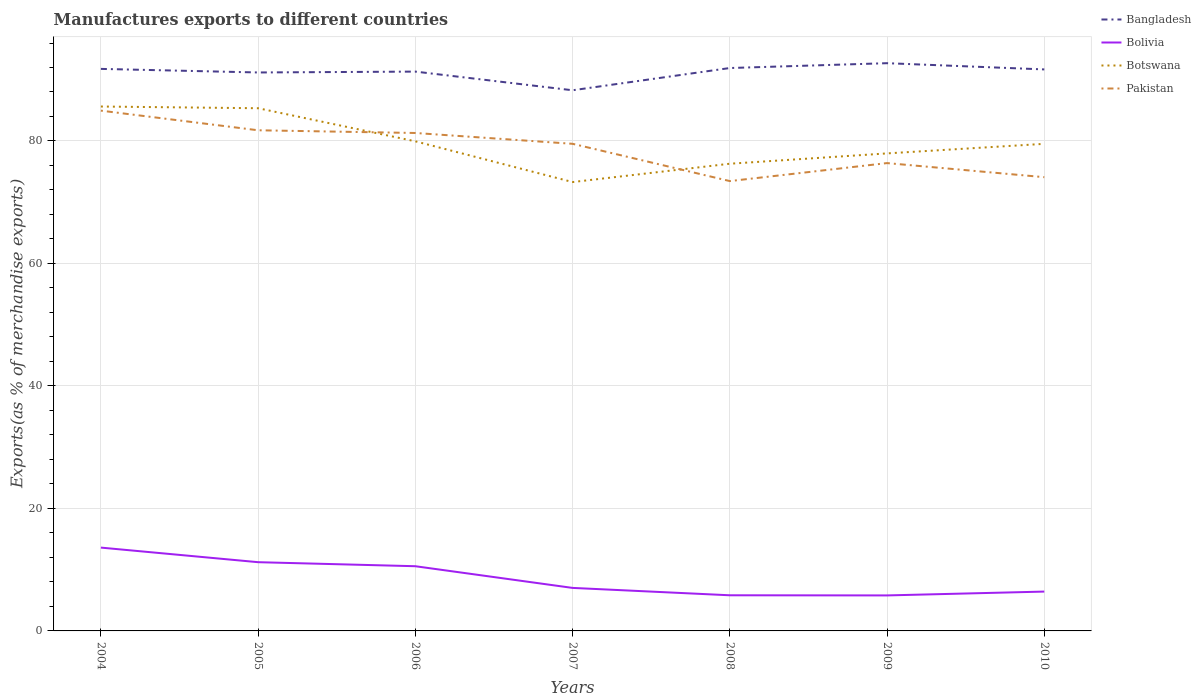Does the line corresponding to Bolivia intersect with the line corresponding to Bangladesh?
Provide a succinct answer. No. Across all years, what is the maximum percentage of exports to different countries in Bolivia?
Offer a terse response. 5.8. In which year was the percentage of exports to different countries in Pakistan maximum?
Keep it short and to the point. 2008. What is the total percentage of exports to different countries in Bangladesh in the graph?
Ensure brevity in your answer.  0.58. What is the difference between the highest and the second highest percentage of exports to different countries in Bolivia?
Your answer should be very brief. 7.81. How many years are there in the graph?
Provide a short and direct response. 7. What is the difference between two consecutive major ticks on the Y-axis?
Ensure brevity in your answer.  20. Does the graph contain grids?
Keep it short and to the point. Yes. How many legend labels are there?
Ensure brevity in your answer.  4. How are the legend labels stacked?
Keep it short and to the point. Vertical. What is the title of the graph?
Your response must be concise. Manufactures exports to different countries. Does "Low income" appear as one of the legend labels in the graph?
Provide a short and direct response. No. What is the label or title of the X-axis?
Your answer should be very brief. Years. What is the label or title of the Y-axis?
Keep it short and to the point. Exports(as % of merchandise exports). What is the Exports(as % of merchandise exports) of Bangladesh in 2004?
Provide a short and direct response. 91.77. What is the Exports(as % of merchandise exports) in Bolivia in 2004?
Offer a terse response. 13.61. What is the Exports(as % of merchandise exports) of Botswana in 2004?
Keep it short and to the point. 85.63. What is the Exports(as % of merchandise exports) of Pakistan in 2004?
Give a very brief answer. 84.96. What is the Exports(as % of merchandise exports) in Bangladesh in 2005?
Offer a terse response. 91.19. What is the Exports(as % of merchandise exports) of Bolivia in 2005?
Your answer should be compact. 11.22. What is the Exports(as % of merchandise exports) of Botswana in 2005?
Offer a terse response. 85.35. What is the Exports(as % of merchandise exports) in Pakistan in 2005?
Offer a very short reply. 81.75. What is the Exports(as % of merchandise exports) of Bangladesh in 2006?
Offer a very short reply. 91.33. What is the Exports(as % of merchandise exports) in Bolivia in 2006?
Your answer should be very brief. 10.56. What is the Exports(as % of merchandise exports) in Botswana in 2006?
Keep it short and to the point. 79.95. What is the Exports(as % of merchandise exports) in Pakistan in 2006?
Keep it short and to the point. 81.31. What is the Exports(as % of merchandise exports) in Bangladesh in 2007?
Your response must be concise. 88.28. What is the Exports(as % of merchandise exports) of Bolivia in 2007?
Give a very brief answer. 7.02. What is the Exports(as % of merchandise exports) in Botswana in 2007?
Provide a succinct answer. 73.3. What is the Exports(as % of merchandise exports) in Pakistan in 2007?
Give a very brief answer. 79.54. What is the Exports(as % of merchandise exports) in Bangladesh in 2008?
Offer a very short reply. 91.92. What is the Exports(as % of merchandise exports) in Bolivia in 2008?
Offer a very short reply. 5.82. What is the Exports(as % of merchandise exports) in Botswana in 2008?
Keep it short and to the point. 76.29. What is the Exports(as % of merchandise exports) in Pakistan in 2008?
Give a very brief answer. 73.45. What is the Exports(as % of merchandise exports) of Bangladesh in 2009?
Provide a short and direct response. 92.7. What is the Exports(as % of merchandise exports) in Bolivia in 2009?
Provide a short and direct response. 5.8. What is the Exports(as % of merchandise exports) of Botswana in 2009?
Your answer should be very brief. 77.97. What is the Exports(as % of merchandise exports) in Pakistan in 2009?
Your answer should be very brief. 76.39. What is the Exports(as % of merchandise exports) in Bangladesh in 2010?
Your answer should be very brief. 91.69. What is the Exports(as % of merchandise exports) of Bolivia in 2010?
Offer a terse response. 6.42. What is the Exports(as % of merchandise exports) in Botswana in 2010?
Give a very brief answer. 79.54. What is the Exports(as % of merchandise exports) of Pakistan in 2010?
Keep it short and to the point. 74.09. Across all years, what is the maximum Exports(as % of merchandise exports) of Bangladesh?
Give a very brief answer. 92.7. Across all years, what is the maximum Exports(as % of merchandise exports) in Bolivia?
Offer a very short reply. 13.61. Across all years, what is the maximum Exports(as % of merchandise exports) in Botswana?
Your answer should be compact. 85.63. Across all years, what is the maximum Exports(as % of merchandise exports) in Pakistan?
Offer a very short reply. 84.96. Across all years, what is the minimum Exports(as % of merchandise exports) of Bangladesh?
Your answer should be compact. 88.28. Across all years, what is the minimum Exports(as % of merchandise exports) of Bolivia?
Ensure brevity in your answer.  5.8. Across all years, what is the minimum Exports(as % of merchandise exports) of Botswana?
Your answer should be very brief. 73.3. Across all years, what is the minimum Exports(as % of merchandise exports) of Pakistan?
Make the answer very short. 73.45. What is the total Exports(as % of merchandise exports) of Bangladesh in the graph?
Ensure brevity in your answer.  638.88. What is the total Exports(as % of merchandise exports) of Bolivia in the graph?
Your response must be concise. 60.46. What is the total Exports(as % of merchandise exports) in Botswana in the graph?
Make the answer very short. 558.02. What is the total Exports(as % of merchandise exports) of Pakistan in the graph?
Your response must be concise. 551.49. What is the difference between the Exports(as % of merchandise exports) in Bangladesh in 2004 and that in 2005?
Give a very brief answer. 0.58. What is the difference between the Exports(as % of merchandise exports) in Bolivia in 2004 and that in 2005?
Offer a very short reply. 2.38. What is the difference between the Exports(as % of merchandise exports) of Botswana in 2004 and that in 2005?
Keep it short and to the point. 0.28. What is the difference between the Exports(as % of merchandise exports) of Pakistan in 2004 and that in 2005?
Provide a succinct answer. 3.21. What is the difference between the Exports(as % of merchandise exports) of Bangladesh in 2004 and that in 2006?
Your answer should be very brief. 0.44. What is the difference between the Exports(as % of merchandise exports) in Bolivia in 2004 and that in 2006?
Your answer should be compact. 3.04. What is the difference between the Exports(as % of merchandise exports) of Botswana in 2004 and that in 2006?
Your answer should be compact. 5.68. What is the difference between the Exports(as % of merchandise exports) of Pakistan in 2004 and that in 2006?
Provide a succinct answer. 3.65. What is the difference between the Exports(as % of merchandise exports) in Bangladesh in 2004 and that in 2007?
Make the answer very short. 3.49. What is the difference between the Exports(as % of merchandise exports) in Bolivia in 2004 and that in 2007?
Your response must be concise. 6.58. What is the difference between the Exports(as % of merchandise exports) of Botswana in 2004 and that in 2007?
Your response must be concise. 12.34. What is the difference between the Exports(as % of merchandise exports) in Pakistan in 2004 and that in 2007?
Provide a succinct answer. 5.42. What is the difference between the Exports(as % of merchandise exports) in Bangladesh in 2004 and that in 2008?
Keep it short and to the point. -0.14. What is the difference between the Exports(as % of merchandise exports) in Bolivia in 2004 and that in 2008?
Provide a succinct answer. 7.78. What is the difference between the Exports(as % of merchandise exports) in Botswana in 2004 and that in 2008?
Offer a very short reply. 9.34. What is the difference between the Exports(as % of merchandise exports) of Pakistan in 2004 and that in 2008?
Provide a short and direct response. 11.5. What is the difference between the Exports(as % of merchandise exports) of Bangladesh in 2004 and that in 2009?
Provide a short and direct response. -0.93. What is the difference between the Exports(as % of merchandise exports) in Bolivia in 2004 and that in 2009?
Offer a terse response. 7.81. What is the difference between the Exports(as % of merchandise exports) in Botswana in 2004 and that in 2009?
Give a very brief answer. 7.66. What is the difference between the Exports(as % of merchandise exports) in Pakistan in 2004 and that in 2009?
Your answer should be compact. 8.56. What is the difference between the Exports(as % of merchandise exports) in Bangladesh in 2004 and that in 2010?
Your answer should be very brief. 0.09. What is the difference between the Exports(as % of merchandise exports) of Bolivia in 2004 and that in 2010?
Give a very brief answer. 7.18. What is the difference between the Exports(as % of merchandise exports) in Botswana in 2004 and that in 2010?
Ensure brevity in your answer.  6.09. What is the difference between the Exports(as % of merchandise exports) of Pakistan in 2004 and that in 2010?
Offer a very short reply. 10.87. What is the difference between the Exports(as % of merchandise exports) of Bangladesh in 2005 and that in 2006?
Ensure brevity in your answer.  -0.14. What is the difference between the Exports(as % of merchandise exports) of Bolivia in 2005 and that in 2006?
Give a very brief answer. 0.66. What is the difference between the Exports(as % of merchandise exports) of Botswana in 2005 and that in 2006?
Keep it short and to the point. 5.4. What is the difference between the Exports(as % of merchandise exports) of Pakistan in 2005 and that in 2006?
Ensure brevity in your answer.  0.44. What is the difference between the Exports(as % of merchandise exports) of Bangladesh in 2005 and that in 2007?
Keep it short and to the point. 2.91. What is the difference between the Exports(as % of merchandise exports) in Bolivia in 2005 and that in 2007?
Your answer should be compact. 4.2. What is the difference between the Exports(as % of merchandise exports) in Botswana in 2005 and that in 2007?
Give a very brief answer. 12.05. What is the difference between the Exports(as % of merchandise exports) of Pakistan in 2005 and that in 2007?
Keep it short and to the point. 2.21. What is the difference between the Exports(as % of merchandise exports) in Bangladesh in 2005 and that in 2008?
Your response must be concise. -0.73. What is the difference between the Exports(as % of merchandise exports) of Bolivia in 2005 and that in 2008?
Your response must be concise. 5.4. What is the difference between the Exports(as % of merchandise exports) of Botswana in 2005 and that in 2008?
Ensure brevity in your answer.  9.06. What is the difference between the Exports(as % of merchandise exports) of Pakistan in 2005 and that in 2008?
Make the answer very short. 8.3. What is the difference between the Exports(as % of merchandise exports) in Bangladesh in 2005 and that in 2009?
Your answer should be very brief. -1.52. What is the difference between the Exports(as % of merchandise exports) of Bolivia in 2005 and that in 2009?
Your answer should be compact. 5.43. What is the difference between the Exports(as % of merchandise exports) of Botswana in 2005 and that in 2009?
Your response must be concise. 7.38. What is the difference between the Exports(as % of merchandise exports) of Pakistan in 2005 and that in 2009?
Offer a terse response. 5.36. What is the difference between the Exports(as % of merchandise exports) in Bangladesh in 2005 and that in 2010?
Keep it short and to the point. -0.5. What is the difference between the Exports(as % of merchandise exports) of Bolivia in 2005 and that in 2010?
Give a very brief answer. 4.8. What is the difference between the Exports(as % of merchandise exports) of Botswana in 2005 and that in 2010?
Your response must be concise. 5.81. What is the difference between the Exports(as % of merchandise exports) in Pakistan in 2005 and that in 2010?
Give a very brief answer. 7.66. What is the difference between the Exports(as % of merchandise exports) in Bangladesh in 2006 and that in 2007?
Your answer should be compact. 3.05. What is the difference between the Exports(as % of merchandise exports) in Bolivia in 2006 and that in 2007?
Offer a terse response. 3.54. What is the difference between the Exports(as % of merchandise exports) in Botswana in 2006 and that in 2007?
Offer a very short reply. 6.65. What is the difference between the Exports(as % of merchandise exports) of Pakistan in 2006 and that in 2007?
Ensure brevity in your answer.  1.77. What is the difference between the Exports(as % of merchandise exports) in Bangladesh in 2006 and that in 2008?
Your answer should be very brief. -0.58. What is the difference between the Exports(as % of merchandise exports) in Bolivia in 2006 and that in 2008?
Provide a succinct answer. 4.74. What is the difference between the Exports(as % of merchandise exports) in Botswana in 2006 and that in 2008?
Make the answer very short. 3.66. What is the difference between the Exports(as % of merchandise exports) in Pakistan in 2006 and that in 2008?
Keep it short and to the point. 7.85. What is the difference between the Exports(as % of merchandise exports) of Bangladesh in 2006 and that in 2009?
Your answer should be very brief. -1.37. What is the difference between the Exports(as % of merchandise exports) of Bolivia in 2006 and that in 2009?
Give a very brief answer. 4.77. What is the difference between the Exports(as % of merchandise exports) in Botswana in 2006 and that in 2009?
Make the answer very short. 1.97. What is the difference between the Exports(as % of merchandise exports) in Pakistan in 2006 and that in 2009?
Ensure brevity in your answer.  4.92. What is the difference between the Exports(as % of merchandise exports) of Bangladesh in 2006 and that in 2010?
Provide a short and direct response. -0.35. What is the difference between the Exports(as % of merchandise exports) in Bolivia in 2006 and that in 2010?
Your response must be concise. 4.14. What is the difference between the Exports(as % of merchandise exports) of Botswana in 2006 and that in 2010?
Provide a short and direct response. 0.41. What is the difference between the Exports(as % of merchandise exports) in Pakistan in 2006 and that in 2010?
Offer a very short reply. 7.22. What is the difference between the Exports(as % of merchandise exports) in Bangladesh in 2007 and that in 2008?
Provide a short and direct response. -3.63. What is the difference between the Exports(as % of merchandise exports) in Bolivia in 2007 and that in 2008?
Your answer should be compact. 1.2. What is the difference between the Exports(as % of merchandise exports) in Botswana in 2007 and that in 2008?
Provide a short and direct response. -2.99. What is the difference between the Exports(as % of merchandise exports) of Pakistan in 2007 and that in 2008?
Keep it short and to the point. 6.09. What is the difference between the Exports(as % of merchandise exports) of Bangladesh in 2007 and that in 2009?
Make the answer very short. -4.42. What is the difference between the Exports(as % of merchandise exports) in Bolivia in 2007 and that in 2009?
Your response must be concise. 1.23. What is the difference between the Exports(as % of merchandise exports) in Botswana in 2007 and that in 2009?
Provide a short and direct response. -4.68. What is the difference between the Exports(as % of merchandise exports) of Pakistan in 2007 and that in 2009?
Provide a short and direct response. 3.15. What is the difference between the Exports(as % of merchandise exports) of Bangladesh in 2007 and that in 2010?
Keep it short and to the point. -3.4. What is the difference between the Exports(as % of merchandise exports) in Bolivia in 2007 and that in 2010?
Offer a terse response. 0.6. What is the difference between the Exports(as % of merchandise exports) in Botswana in 2007 and that in 2010?
Make the answer very short. -6.24. What is the difference between the Exports(as % of merchandise exports) in Pakistan in 2007 and that in 2010?
Your answer should be compact. 5.45. What is the difference between the Exports(as % of merchandise exports) of Bangladesh in 2008 and that in 2009?
Offer a terse response. -0.79. What is the difference between the Exports(as % of merchandise exports) in Bolivia in 2008 and that in 2009?
Your response must be concise. 0.02. What is the difference between the Exports(as % of merchandise exports) of Botswana in 2008 and that in 2009?
Offer a very short reply. -1.69. What is the difference between the Exports(as % of merchandise exports) in Pakistan in 2008 and that in 2009?
Keep it short and to the point. -2.94. What is the difference between the Exports(as % of merchandise exports) of Bangladesh in 2008 and that in 2010?
Provide a succinct answer. 0.23. What is the difference between the Exports(as % of merchandise exports) of Bolivia in 2008 and that in 2010?
Offer a very short reply. -0.6. What is the difference between the Exports(as % of merchandise exports) in Botswana in 2008 and that in 2010?
Offer a very short reply. -3.25. What is the difference between the Exports(as % of merchandise exports) in Pakistan in 2008 and that in 2010?
Make the answer very short. -0.64. What is the difference between the Exports(as % of merchandise exports) of Bangladesh in 2009 and that in 2010?
Keep it short and to the point. 1.02. What is the difference between the Exports(as % of merchandise exports) in Bolivia in 2009 and that in 2010?
Make the answer very short. -0.63. What is the difference between the Exports(as % of merchandise exports) of Botswana in 2009 and that in 2010?
Your answer should be compact. -1.56. What is the difference between the Exports(as % of merchandise exports) of Pakistan in 2009 and that in 2010?
Make the answer very short. 2.3. What is the difference between the Exports(as % of merchandise exports) in Bangladesh in 2004 and the Exports(as % of merchandise exports) in Bolivia in 2005?
Keep it short and to the point. 80.55. What is the difference between the Exports(as % of merchandise exports) of Bangladesh in 2004 and the Exports(as % of merchandise exports) of Botswana in 2005?
Make the answer very short. 6.42. What is the difference between the Exports(as % of merchandise exports) of Bangladesh in 2004 and the Exports(as % of merchandise exports) of Pakistan in 2005?
Keep it short and to the point. 10.02. What is the difference between the Exports(as % of merchandise exports) of Bolivia in 2004 and the Exports(as % of merchandise exports) of Botswana in 2005?
Offer a terse response. -71.74. What is the difference between the Exports(as % of merchandise exports) in Bolivia in 2004 and the Exports(as % of merchandise exports) in Pakistan in 2005?
Offer a very short reply. -68.14. What is the difference between the Exports(as % of merchandise exports) in Botswana in 2004 and the Exports(as % of merchandise exports) in Pakistan in 2005?
Your response must be concise. 3.88. What is the difference between the Exports(as % of merchandise exports) in Bangladesh in 2004 and the Exports(as % of merchandise exports) in Bolivia in 2006?
Your response must be concise. 81.21. What is the difference between the Exports(as % of merchandise exports) in Bangladesh in 2004 and the Exports(as % of merchandise exports) in Botswana in 2006?
Provide a short and direct response. 11.83. What is the difference between the Exports(as % of merchandise exports) in Bangladesh in 2004 and the Exports(as % of merchandise exports) in Pakistan in 2006?
Provide a short and direct response. 10.47. What is the difference between the Exports(as % of merchandise exports) of Bolivia in 2004 and the Exports(as % of merchandise exports) of Botswana in 2006?
Ensure brevity in your answer.  -66.34. What is the difference between the Exports(as % of merchandise exports) of Bolivia in 2004 and the Exports(as % of merchandise exports) of Pakistan in 2006?
Keep it short and to the point. -67.7. What is the difference between the Exports(as % of merchandise exports) in Botswana in 2004 and the Exports(as % of merchandise exports) in Pakistan in 2006?
Keep it short and to the point. 4.32. What is the difference between the Exports(as % of merchandise exports) in Bangladesh in 2004 and the Exports(as % of merchandise exports) in Bolivia in 2007?
Provide a succinct answer. 84.75. What is the difference between the Exports(as % of merchandise exports) of Bangladesh in 2004 and the Exports(as % of merchandise exports) of Botswana in 2007?
Offer a very short reply. 18.48. What is the difference between the Exports(as % of merchandise exports) of Bangladesh in 2004 and the Exports(as % of merchandise exports) of Pakistan in 2007?
Your answer should be compact. 12.23. What is the difference between the Exports(as % of merchandise exports) of Bolivia in 2004 and the Exports(as % of merchandise exports) of Botswana in 2007?
Your answer should be compact. -59.69. What is the difference between the Exports(as % of merchandise exports) of Bolivia in 2004 and the Exports(as % of merchandise exports) of Pakistan in 2007?
Give a very brief answer. -65.93. What is the difference between the Exports(as % of merchandise exports) in Botswana in 2004 and the Exports(as % of merchandise exports) in Pakistan in 2007?
Keep it short and to the point. 6.09. What is the difference between the Exports(as % of merchandise exports) of Bangladesh in 2004 and the Exports(as % of merchandise exports) of Bolivia in 2008?
Make the answer very short. 85.95. What is the difference between the Exports(as % of merchandise exports) in Bangladesh in 2004 and the Exports(as % of merchandise exports) in Botswana in 2008?
Offer a terse response. 15.49. What is the difference between the Exports(as % of merchandise exports) in Bangladesh in 2004 and the Exports(as % of merchandise exports) in Pakistan in 2008?
Give a very brief answer. 18.32. What is the difference between the Exports(as % of merchandise exports) in Bolivia in 2004 and the Exports(as % of merchandise exports) in Botswana in 2008?
Give a very brief answer. -62.68. What is the difference between the Exports(as % of merchandise exports) of Bolivia in 2004 and the Exports(as % of merchandise exports) of Pakistan in 2008?
Your answer should be compact. -59.85. What is the difference between the Exports(as % of merchandise exports) in Botswana in 2004 and the Exports(as % of merchandise exports) in Pakistan in 2008?
Your answer should be compact. 12.18. What is the difference between the Exports(as % of merchandise exports) in Bangladesh in 2004 and the Exports(as % of merchandise exports) in Bolivia in 2009?
Provide a short and direct response. 85.98. What is the difference between the Exports(as % of merchandise exports) in Bangladesh in 2004 and the Exports(as % of merchandise exports) in Botswana in 2009?
Make the answer very short. 13.8. What is the difference between the Exports(as % of merchandise exports) in Bangladesh in 2004 and the Exports(as % of merchandise exports) in Pakistan in 2009?
Keep it short and to the point. 15.38. What is the difference between the Exports(as % of merchandise exports) of Bolivia in 2004 and the Exports(as % of merchandise exports) of Botswana in 2009?
Give a very brief answer. -64.37. What is the difference between the Exports(as % of merchandise exports) in Bolivia in 2004 and the Exports(as % of merchandise exports) in Pakistan in 2009?
Your answer should be compact. -62.79. What is the difference between the Exports(as % of merchandise exports) of Botswana in 2004 and the Exports(as % of merchandise exports) of Pakistan in 2009?
Ensure brevity in your answer.  9.24. What is the difference between the Exports(as % of merchandise exports) of Bangladesh in 2004 and the Exports(as % of merchandise exports) of Bolivia in 2010?
Keep it short and to the point. 85.35. What is the difference between the Exports(as % of merchandise exports) of Bangladesh in 2004 and the Exports(as % of merchandise exports) of Botswana in 2010?
Offer a terse response. 12.24. What is the difference between the Exports(as % of merchandise exports) in Bangladesh in 2004 and the Exports(as % of merchandise exports) in Pakistan in 2010?
Make the answer very short. 17.68. What is the difference between the Exports(as % of merchandise exports) of Bolivia in 2004 and the Exports(as % of merchandise exports) of Botswana in 2010?
Give a very brief answer. -65.93. What is the difference between the Exports(as % of merchandise exports) in Bolivia in 2004 and the Exports(as % of merchandise exports) in Pakistan in 2010?
Your answer should be very brief. -60.49. What is the difference between the Exports(as % of merchandise exports) of Botswana in 2004 and the Exports(as % of merchandise exports) of Pakistan in 2010?
Ensure brevity in your answer.  11.54. What is the difference between the Exports(as % of merchandise exports) of Bangladesh in 2005 and the Exports(as % of merchandise exports) of Bolivia in 2006?
Offer a very short reply. 80.63. What is the difference between the Exports(as % of merchandise exports) of Bangladesh in 2005 and the Exports(as % of merchandise exports) of Botswana in 2006?
Your answer should be compact. 11.24. What is the difference between the Exports(as % of merchandise exports) of Bangladesh in 2005 and the Exports(as % of merchandise exports) of Pakistan in 2006?
Offer a terse response. 9.88. What is the difference between the Exports(as % of merchandise exports) in Bolivia in 2005 and the Exports(as % of merchandise exports) in Botswana in 2006?
Provide a succinct answer. -68.72. What is the difference between the Exports(as % of merchandise exports) of Bolivia in 2005 and the Exports(as % of merchandise exports) of Pakistan in 2006?
Make the answer very short. -70.08. What is the difference between the Exports(as % of merchandise exports) in Botswana in 2005 and the Exports(as % of merchandise exports) in Pakistan in 2006?
Keep it short and to the point. 4.04. What is the difference between the Exports(as % of merchandise exports) of Bangladesh in 2005 and the Exports(as % of merchandise exports) of Bolivia in 2007?
Give a very brief answer. 84.17. What is the difference between the Exports(as % of merchandise exports) of Bangladesh in 2005 and the Exports(as % of merchandise exports) of Botswana in 2007?
Offer a very short reply. 17.89. What is the difference between the Exports(as % of merchandise exports) of Bangladesh in 2005 and the Exports(as % of merchandise exports) of Pakistan in 2007?
Offer a terse response. 11.65. What is the difference between the Exports(as % of merchandise exports) of Bolivia in 2005 and the Exports(as % of merchandise exports) of Botswana in 2007?
Your answer should be very brief. -62.07. What is the difference between the Exports(as % of merchandise exports) of Bolivia in 2005 and the Exports(as % of merchandise exports) of Pakistan in 2007?
Make the answer very short. -68.32. What is the difference between the Exports(as % of merchandise exports) of Botswana in 2005 and the Exports(as % of merchandise exports) of Pakistan in 2007?
Provide a short and direct response. 5.81. What is the difference between the Exports(as % of merchandise exports) of Bangladesh in 2005 and the Exports(as % of merchandise exports) of Bolivia in 2008?
Make the answer very short. 85.37. What is the difference between the Exports(as % of merchandise exports) of Bangladesh in 2005 and the Exports(as % of merchandise exports) of Botswana in 2008?
Your response must be concise. 14.9. What is the difference between the Exports(as % of merchandise exports) of Bangladesh in 2005 and the Exports(as % of merchandise exports) of Pakistan in 2008?
Offer a terse response. 17.74. What is the difference between the Exports(as % of merchandise exports) of Bolivia in 2005 and the Exports(as % of merchandise exports) of Botswana in 2008?
Offer a terse response. -65.06. What is the difference between the Exports(as % of merchandise exports) in Bolivia in 2005 and the Exports(as % of merchandise exports) in Pakistan in 2008?
Ensure brevity in your answer.  -62.23. What is the difference between the Exports(as % of merchandise exports) of Botswana in 2005 and the Exports(as % of merchandise exports) of Pakistan in 2008?
Give a very brief answer. 11.9. What is the difference between the Exports(as % of merchandise exports) of Bangladesh in 2005 and the Exports(as % of merchandise exports) of Bolivia in 2009?
Provide a short and direct response. 85.39. What is the difference between the Exports(as % of merchandise exports) of Bangladesh in 2005 and the Exports(as % of merchandise exports) of Botswana in 2009?
Ensure brevity in your answer.  13.22. What is the difference between the Exports(as % of merchandise exports) of Bangladesh in 2005 and the Exports(as % of merchandise exports) of Pakistan in 2009?
Give a very brief answer. 14.8. What is the difference between the Exports(as % of merchandise exports) in Bolivia in 2005 and the Exports(as % of merchandise exports) in Botswana in 2009?
Give a very brief answer. -66.75. What is the difference between the Exports(as % of merchandise exports) of Bolivia in 2005 and the Exports(as % of merchandise exports) of Pakistan in 2009?
Ensure brevity in your answer.  -65.17. What is the difference between the Exports(as % of merchandise exports) of Botswana in 2005 and the Exports(as % of merchandise exports) of Pakistan in 2009?
Ensure brevity in your answer.  8.96. What is the difference between the Exports(as % of merchandise exports) in Bangladesh in 2005 and the Exports(as % of merchandise exports) in Bolivia in 2010?
Make the answer very short. 84.76. What is the difference between the Exports(as % of merchandise exports) of Bangladesh in 2005 and the Exports(as % of merchandise exports) of Botswana in 2010?
Your response must be concise. 11.65. What is the difference between the Exports(as % of merchandise exports) in Bangladesh in 2005 and the Exports(as % of merchandise exports) in Pakistan in 2010?
Your answer should be very brief. 17.1. What is the difference between the Exports(as % of merchandise exports) of Bolivia in 2005 and the Exports(as % of merchandise exports) of Botswana in 2010?
Your response must be concise. -68.31. What is the difference between the Exports(as % of merchandise exports) of Bolivia in 2005 and the Exports(as % of merchandise exports) of Pakistan in 2010?
Your answer should be very brief. -62.87. What is the difference between the Exports(as % of merchandise exports) of Botswana in 2005 and the Exports(as % of merchandise exports) of Pakistan in 2010?
Your answer should be compact. 11.26. What is the difference between the Exports(as % of merchandise exports) of Bangladesh in 2006 and the Exports(as % of merchandise exports) of Bolivia in 2007?
Your answer should be compact. 84.31. What is the difference between the Exports(as % of merchandise exports) in Bangladesh in 2006 and the Exports(as % of merchandise exports) in Botswana in 2007?
Provide a short and direct response. 18.04. What is the difference between the Exports(as % of merchandise exports) in Bangladesh in 2006 and the Exports(as % of merchandise exports) in Pakistan in 2007?
Offer a very short reply. 11.79. What is the difference between the Exports(as % of merchandise exports) in Bolivia in 2006 and the Exports(as % of merchandise exports) in Botswana in 2007?
Your answer should be compact. -62.73. What is the difference between the Exports(as % of merchandise exports) of Bolivia in 2006 and the Exports(as % of merchandise exports) of Pakistan in 2007?
Make the answer very short. -68.98. What is the difference between the Exports(as % of merchandise exports) of Botswana in 2006 and the Exports(as % of merchandise exports) of Pakistan in 2007?
Your answer should be compact. 0.41. What is the difference between the Exports(as % of merchandise exports) of Bangladesh in 2006 and the Exports(as % of merchandise exports) of Bolivia in 2008?
Keep it short and to the point. 85.51. What is the difference between the Exports(as % of merchandise exports) in Bangladesh in 2006 and the Exports(as % of merchandise exports) in Botswana in 2008?
Your answer should be very brief. 15.04. What is the difference between the Exports(as % of merchandise exports) in Bangladesh in 2006 and the Exports(as % of merchandise exports) in Pakistan in 2008?
Offer a very short reply. 17.88. What is the difference between the Exports(as % of merchandise exports) of Bolivia in 2006 and the Exports(as % of merchandise exports) of Botswana in 2008?
Offer a very short reply. -65.72. What is the difference between the Exports(as % of merchandise exports) of Bolivia in 2006 and the Exports(as % of merchandise exports) of Pakistan in 2008?
Your answer should be very brief. -62.89. What is the difference between the Exports(as % of merchandise exports) of Botswana in 2006 and the Exports(as % of merchandise exports) of Pakistan in 2008?
Ensure brevity in your answer.  6.49. What is the difference between the Exports(as % of merchandise exports) in Bangladesh in 2006 and the Exports(as % of merchandise exports) in Bolivia in 2009?
Ensure brevity in your answer.  85.53. What is the difference between the Exports(as % of merchandise exports) in Bangladesh in 2006 and the Exports(as % of merchandise exports) in Botswana in 2009?
Make the answer very short. 13.36. What is the difference between the Exports(as % of merchandise exports) of Bangladesh in 2006 and the Exports(as % of merchandise exports) of Pakistan in 2009?
Offer a terse response. 14.94. What is the difference between the Exports(as % of merchandise exports) in Bolivia in 2006 and the Exports(as % of merchandise exports) in Botswana in 2009?
Provide a short and direct response. -67.41. What is the difference between the Exports(as % of merchandise exports) of Bolivia in 2006 and the Exports(as % of merchandise exports) of Pakistan in 2009?
Give a very brief answer. -65.83. What is the difference between the Exports(as % of merchandise exports) of Botswana in 2006 and the Exports(as % of merchandise exports) of Pakistan in 2009?
Your response must be concise. 3.56. What is the difference between the Exports(as % of merchandise exports) of Bangladesh in 2006 and the Exports(as % of merchandise exports) of Bolivia in 2010?
Your answer should be compact. 84.91. What is the difference between the Exports(as % of merchandise exports) of Bangladesh in 2006 and the Exports(as % of merchandise exports) of Botswana in 2010?
Your answer should be compact. 11.8. What is the difference between the Exports(as % of merchandise exports) in Bangladesh in 2006 and the Exports(as % of merchandise exports) in Pakistan in 2010?
Your answer should be compact. 17.24. What is the difference between the Exports(as % of merchandise exports) in Bolivia in 2006 and the Exports(as % of merchandise exports) in Botswana in 2010?
Provide a succinct answer. -68.97. What is the difference between the Exports(as % of merchandise exports) in Bolivia in 2006 and the Exports(as % of merchandise exports) in Pakistan in 2010?
Offer a terse response. -63.53. What is the difference between the Exports(as % of merchandise exports) of Botswana in 2006 and the Exports(as % of merchandise exports) of Pakistan in 2010?
Provide a succinct answer. 5.86. What is the difference between the Exports(as % of merchandise exports) of Bangladesh in 2007 and the Exports(as % of merchandise exports) of Bolivia in 2008?
Offer a very short reply. 82.46. What is the difference between the Exports(as % of merchandise exports) in Bangladesh in 2007 and the Exports(as % of merchandise exports) in Botswana in 2008?
Keep it short and to the point. 12. What is the difference between the Exports(as % of merchandise exports) of Bangladesh in 2007 and the Exports(as % of merchandise exports) of Pakistan in 2008?
Make the answer very short. 14.83. What is the difference between the Exports(as % of merchandise exports) of Bolivia in 2007 and the Exports(as % of merchandise exports) of Botswana in 2008?
Provide a succinct answer. -69.26. What is the difference between the Exports(as % of merchandise exports) in Bolivia in 2007 and the Exports(as % of merchandise exports) in Pakistan in 2008?
Ensure brevity in your answer.  -66.43. What is the difference between the Exports(as % of merchandise exports) of Botswana in 2007 and the Exports(as % of merchandise exports) of Pakistan in 2008?
Ensure brevity in your answer.  -0.16. What is the difference between the Exports(as % of merchandise exports) in Bangladesh in 2007 and the Exports(as % of merchandise exports) in Bolivia in 2009?
Offer a terse response. 82.49. What is the difference between the Exports(as % of merchandise exports) of Bangladesh in 2007 and the Exports(as % of merchandise exports) of Botswana in 2009?
Your answer should be very brief. 10.31. What is the difference between the Exports(as % of merchandise exports) of Bangladesh in 2007 and the Exports(as % of merchandise exports) of Pakistan in 2009?
Offer a terse response. 11.89. What is the difference between the Exports(as % of merchandise exports) of Bolivia in 2007 and the Exports(as % of merchandise exports) of Botswana in 2009?
Give a very brief answer. -70.95. What is the difference between the Exports(as % of merchandise exports) of Bolivia in 2007 and the Exports(as % of merchandise exports) of Pakistan in 2009?
Offer a terse response. -69.37. What is the difference between the Exports(as % of merchandise exports) in Botswana in 2007 and the Exports(as % of merchandise exports) in Pakistan in 2009?
Offer a very short reply. -3.1. What is the difference between the Exports(as % of merchandise exports) of Bangladesh in 2007 and the Exports(as % of merchandise exports) of Bolivia in 2010?
Give a very brief answer. 81.86. What is the difference between the Exports(as % of merchandise exports) of Bangladesh in 2007 and the Exports(as % of merchandise exports) of Botswana in 2010?
Make the answer very short. 8.75. What is the difference between the Exports(as % of merchandise exports) of Bangladesh in 2007 and the Exports(as % of merchandise exports) of Pakistan in 2010?
Offer a terse response. 14.19. What is the difference between the Exports(as % of merchandise exports) in Bolivia in 2007 and the Exports(as % of merchandise exports) in Botswana in 2010?
Your response must be concise. -72.51. What is the difference between the Exports(as % of merchandise exports) in Bolivia in 2007 and the Exports(as % of merchandise exports) in Pakistan in 2010?
Offer a very short reply. -67.07. What is the difference between the Exports(as % of merchandise exports) of Botswana in 2007 and the Exports(as % of merchandise exports) of Pakistan in 2010?
Provide a succinct answer. -0.8. What is the difference between the Exports(as % of merchandise exports) in Bangladesh in 2008 and the Exports(as % of merchandise exports) in Bolivia in 2009?
Provide a short and direct response. 86.12. What is the difference between the Exports(as % of merchandise exports) in Bangladesh in 2008 and the Exports(as % of merchandise exports) in Botswana in 2009?
Give a very brief answer. 13.94. What is the difference between the Exports(as % of merchandise exports) in Bangladesh in 2008 and the Exports(as % of merchandise exports) in Pakistan in 2009?
Ensure brevity in your answer.  15.52. What is the difference between the Exports(as % of merchandise exports) of Bolivia in 2008 and the Exports(as % of merchandise exports) of Botswana in 2009?
Your answer should be compact. -72.15. What is the difference between the Exports(as % of merchandise exports) in Bolivia in 2008 and the Exports(as % of merchandise exports) in Pakistan in 2009?
Offer a terse response. -70.57. What is the difference between the Exports(as % of merchandise exports) in Botswana in 2008 and the Exports(as % of merchandise exports) in Pakistan in 2009?
Offer a terse response. -0.1. What is the difference between the Exports(as % of merchandise exports) of Bangladesh in 2008 and the Exports(as % of merchandise exports) of Bolivia in 2010?
Keep it short and to the point. 85.49. What is the difference between the Exports(as % of merchandise exports) of Bangladesh in 2008 and the Exports(as % of merchandise exports) of Botswana in 2010?
Your answer should be very brief. 12.38. What is the difference between the Exports(as % of merchandise exports) of Bangladesh in 2008 and the Exports(as % of merchandise exports) of Pakistan in 2010?
Offer a very short reply. 17.82. What is the difference between the Exports(as % of merchandise exports) of Bolivia in 2008 and the Exports(as % of merchandise exports) of Botswana in 2010?
Your response must be concise. -73.72. What is the difference between the Exports(as % of merchandise exports) in Bolivia in 2008 and the Exports(as % of merchandise exports) in Pakistan in 2010?
Provide a succinct answer. -68.27. What is the difference between the Exports(as % of merchandise exports) in Botswana in 2008 and the Exports(as % of merchandise exports) in Pakistan in 2010?
Provide a short and direct response. 2.2. What is the difference between the Exports(as % of merchandise exports) in Bangladesh in 2009 and the Exports(as % of merchandise exports) in Bolivia in 2010?
Your answer should be compact. 86.28. What is the difference between the Exports(as % of merchandise exports) of Bangladesh in 2009 and the Exports(as % of merchandise exports) of Botswana in 2010?
Provide a short and direct response. 13.17. What is the difference between the Exports(as % of merchandise exports) in Bangladesh in 2009 and the Exports(as % of merchandise exports) in Pakistan in 2010?
Offer a very short reply. 18.61. What is the difference between the Exports(as % of merchandise exports) in Bolivia in 2009 and the Exports(as % of merchandise exports) in Botswana in 2010?
Ensure brevity in your answer.  -73.74. What is the difference between the Exports(as % of merchandise exports) of Bolivia in 2009 and the Exports(as % of merchandise exports) of Pakistan in 2010?
Keep it short and to the point. -68.29. What is the difference between the Exports(as % of merchandise exports) of Botswana in 2009 and the Exports(as % of merchandise exports) of Pakistan in 2010?
Offer a terse response. 3.88. What is the average Exports(as % of merchandise exports) in Bangladesh per year?
Your answer should be compact. 91.27. What is the average Exports(as % of merchandise exports) in Bolivia per year?
Offer a very short reply. 8.64. What is the average Exports(as % of merchandise exports) of Botswana per year?
Make the answer very short. 79.72. What is the average Exports(as % of merchandise exports) in Pakistan per year?
Your answer should be very brief. 78.78. In the year 2004, what is the difference between the Exports(as % of merchandise exports) of Bangladesh and Exports(as % of merchandise exports) of Bolivia?
Keep it short and to the point. 78.17. In the year 2004, what is the difference between the Exports(as % of merchandise exports) of Bangladesh and Exports(as % of merchandise exports) of Botswana?
Offer a terse response. 6.14. In the year 2004, what is the difference between the Exports(as % of merchandise exports) in Bangladesh and Exports(as % of merchandise exports) in Pakistan?
Make the answer very short. 6.82. In the year 2004, what is the difference between the Exports(as % of merchandise exports) in Bolivia and Exports(as % of merchandise exports) in Botswana?
Provide a succinct answer. -72.03. In the year 2004, what is the difference between the Exports(as % of merchandise exports) of Bolivia and Exports(as % of merchandise exports) of Pakistan?
Give a very brief answer. -71.35. In the year 2004, what is the difference between the Exports(as % of merchandise exports) in Botswana and Exports(as % of merchandise exports) in Pakistan?
Your answer should be compact. 0.67. In the year 2005, what is the difference between the Exports(as % of merchandise exports) of Bangladesh and Exports(as % of merchandise exports) of Bolivia?
Your answer should be very brief. 79.97. In the year 2005, what is the difference between the Exports(as % of merchandise exports) of Bangladesh and Exports(as % of merchandise exports) of Botswana?
Make the answer very short. 5.84. In the year 2005, what is the difference between the Exports(as % of merchandise exports) of Bangladesh and Exports(as % of merchandise exports) of Pakistan?
Your response must be concise. 9.44. In the year 2005, what is the difference between the Exports(as % of merchandise exports) in Bolivia and Exports(as % of merchandise exports) in Botswana?
Make the answer very short. -74.13. In the year 2005, what is the difference between the Exports(as % of merchandise exports) in Bolivia and Exports(as % of merchandise exports) in Pakistan?
Your answer should be compact. -70.53. In the year 2005, what is the difference between the Exports(as % of merchandise exports) of Botswana and Exports(as % of merchandise exports) of Pakistan?
Offer a very short reply. 3.6. In the year 2006, what is the difference between the Exports(as % of merchandise exports) of Bangladesh and Exports(as % of merchandise exports) of Bolivia?
Your answer should be compact. 80.77. In the year 2006, what is the difference between the Exports(as % of merchandise exports) of Bangladesh and Exports(as % of merchandise exports) of Botswana?
Provide a succinct answer. 11.38. In the year 2006, what is the difference between the Exports(as % of merchandise exports) of Bangladesh and Exports(as % of merchandise exports) of Pakistan?
Ensure brevity in your answer.  10.02. In the year 2006, what is the difference between the Exports(as % of merchandise exports) of Bolivia and Exports(as % of merchandise exports) of Botswana?
Provide a short and direct response. -69.38. In the year 2006, what is the difference between the Exports(as % of merchandise exports) in Bolivia and Exports(as % of merchandise exports) in Pakistan?
Your answer should be compact. -70.74. In the year 2006, what is the difference between the Exports(as % of merchandise exports) of Botswana and Exports(as % of merchandise exports) of Pakistan?
Provide a short and direct response. -1.36. In the year 2007, what is the difference between the Exports(as % of merchandise exports) of Bangladesh and Exports(as % of merchandise exports) of Bolivia?
Your response must be concise. 81.26. In the year 2007, what is the difference between the Exports(as % of merchandise exports) in Bangladesh and Exports(as % of merchandise exports) in Botswana?
Provide a succinct answer. 14.99. In the year 2007, what is the difference between the Exports(as % of merchandise exports) in Bangladesh and Exports(as % of merchandise exports) in Pakistan?
Your answer should be very brief. 8.74. In the year 2007, what is the difference between the Exports(as % of merchandise exports) in Bolivia and Exports(as % of merchandise exports) in Botswana?
Your answer should be compact. -66.27. In the year 2007, what is the difference between the Exports(as % of merchandise exports) of Bolivia and Exports(as % of merchandise exports) of Pakistan?
Provide a succinct answer. -72.52. In the year 2007, what is the difference between the Exports(as % of merchandise exports) of Botswana and Exports(as % of merchandise exports) of Pakistan?
Ensure brevity in your answer.  -6.25. In the year 2008, what is the difference between the Exports(as % of merchandise exports) in Bangladesh and Exports(as % of merchandise exports) in Bolivia?
Offer a terse response. 86.09. In the year 2008, what is the difference between the Exports(as % of merchandise exports) of Bangladesh and Exports(as % of merchandise exports) of Botswana?
Give a very brief answer. 15.63. In the year 2008, what is the difference between the Exports(as % of merchandise exports) in Bangladesh and Exports(as % of merchandise exports) in Pakistan?
Make the answer very short. 18.46. In the year 2008, what is the difference between the Exports(as % of merchandise exports) of Bolivia and Exports(as % of merchandise exports) of Botswana?
Offer a terse response. -70.47. In the year 2008, what is the difference between the Exports(as % of merchandise exports) of Bolivia and Exports(as % of merchandise exports) of Pakistan?
Offer a terse response. -67.63. In the year 2008, what is the difference between the Exports(as % of merchandise exports) in Botswana and Exports(as % of merchandise exports) in Pakistan?
Offer a terse response. 2.83. In the year 2009, what is the difference between the Exports(as % of merchandise exports) in Bangladesh and Exports(as % of merchandise exports) in Bolivia?
Provide a succinct answer. 86.91. In the year 2009, what is the difference between the Exports(as % of merchandise exports) of Bangladesh and Exports(as % of merchandise exports) of Botswana?
Provide a succinct answer. 14.73. In the year 2009, what is the difference between the Exports(as % of merchandise exports) in Bangladesh and Exports(as % of merchandise exports) in Pakistan?
Your response must be concise. 16.31. In the year 2009, what is the difference between the Exports(as % of merchandise exports) of Bolivia and Exports(as % of merchandise exports) of Botswana?
Provide a short and direct response. -72.18. In the year 2009, what is the difference between the Exports(as % of merchandise exports) in Bolivia and Exports(as % of merchandise exports) in Pakistan?
Make the answer very short. -70.59. In the year 2009, what is the difference between the Exports(as % of merchandise exports) in Botswana and Exports(as % of merchandise exports) in Pakistan?
Ensure brevity in your answer.  1.58. In the year 2010, what is the difference between the Exports(as % of merchandise exports) of Bangladesh and Exports(as % of merchandise exports) of Bolivia?
Ensure brevity in your answer.  85.26. In the year 2010, what is the difference between the Exports(as % of merchandise exports) of Bangladesh and Exports(as % of merchandise exports) of Botswana?
Provide a short and direct response. 12.15. In the year 2010, what is the difference between the Exports(as % of merchandise exports) in Bangladesh and Exports(as % of merchandise exports) in Pakistan?
Your response must be concise. 17.6. In the year 2010, what is the difference between the Exports(as % of merchandise exports) in Bolivia and Exports(as % of merchandise exports) in Botswana?
Give a very brief answer. -73.11. In the year 2010, what is the difference between the Exports(as % of merchandise exports) in Bolivia and Exports(as % of merchandise exports) in Pakistan?
Keep it short and to the point. -67.67. In the year 2010, what is the difference between the Exports(as % of merchandise exports) in Botswana and Exports(as % of merchandise exports) in Pakistan?
Provide a short and direct response. 5.45. What is the ratio of the Exports(as % of merchandise exports) of Bangladesh in 2004 to that in 2005?
Give a very brief answer. 1.01. What is the ratio of the Exports(as % of merchandise exports) of Bolivia in 2004 to that in 2005?
Provide a succinct answer. 1.21. What is the ratio of the Exports(as % of merchandise exports) of Pakistan in 2004 to that in 2005?
Offer a very short reply. 1.04. What is the ratio of the Exports(as % of merchandise exports) in Bangladesh in 2004 to that in 2006?
Keep it short and to the point. 1. What is the ratio of the Exports(as % of merchandise exports) of Bolivia in 2004 to that in 2006?
Offer a terse response. 1.29. What is the ratio of the Exports(as % of merchandise exports) of Botswana in 2004 to that in 2006?
Your response must be concise. 1.07. What is the ratio of the Exports(as % of merchandise exports) in Pakistan in 2004 to that in 2006?
Provide a short and direct response. 1.04. What is the ratio of the Exports(as % of merchandise exports) of Bangladesh in 2004 to that in 2007?
Provide a succinct answer. 1.04. What is the ratio of the Exports(as % of merchandise exports) in Bolivia in 2004 to that in 2007?
Offer a terse response. 1.94. What is the ratio of the Exports(as % of merchandise exports) in Botswana in 2004 to that in 2007?
Your response must be concise. 1.17. What is the ratio of the Exports(as % of merchandise exports) of Pakistan in 2004 to that in 2007?
Offer a terse response. 1.07. What is the ratio of the Exports(as % of merchandise exports) in Bolivia in 2004 to that in 2008?
Give a very brief answer. 2.34. What is the ratio of the Exports(as % of merchandise exports) in Botswana in 2004 to that in 2008?
Your response must be concise. 1.12. What is the ratio of the Exports(as % of merchandise exports) of Pakistan in 2004 to that in 2008?
Make the answer very short. 1.16. What is the ratio of the Exports(as % of merchandise exports) of Bangladesh in 2004 to that in 2009?
Provide a succinct answer. 0.99. What is the ratio of the Exports(as % of merchandise exports) of Bolivia in 2004 to that in 2009?
Keep it short and to the point. 2.35. What is the ratio of the Exports(as % of merchandise exports) in Botswana in 2004 to that in 2009?
Ensure brevity in your answer.  1.1. What is the ratio of the Exports(as % of merchandise exports) of Pakistan in 2004 to that in 2009?
Provide a succinct answer. 1.11. What is the ratio of the Exports(as % of merchandise exports) of Bangladesh in 2004 to that in 2010?
Offer a terse response. 1. What is the ratio of the Exports(as % of merchandise exports) in Bolivia in 2004 to that in 2010?
Your response must be concise. 2.12. What is the ratio of the Exports(as % of merchandise exports) in Botswana in 2004 to that in 2010?
Give a very brief answer. 1.08. What is the ratio of the Exports(as % of merchandise exports) of Pakistan in 2004 to that in 2010?
Your answer should be compact. 1.15. What is the ratio of the Exports(as % of merchandise exports) of Bangladesh in 2005 to that in 2006?
Ensure brevity in your answer.  1. What is the ratio of the Exports(as % of merchandise exports) of Bolivia in 2005 to that in 2006?
Make the answer very short. 1.06. What is the ratio of the Exports(as % of merchandise exports) of Botswana in 2005 to that in 2006?
Provide a succinct answer. 1.07. What is the ratio of the Exports(as % of merchandise exports) in Pakistan in 2005 to that in 2006?
Provide a short and direct response. 1.01. What is the ratio of the Exports(as % of merchandise exports) in Bangladesh in 2005 to that in 2007?
Provide a short and direct response. 1.03. What is the ratio of the Exports(as % of merchandise exports) in Bolivia in 2005 to that in 2007?
Offer a terse response. 1.6. What is the ratio of the Exports(as % of merchandise exports) in Botswana in 2005 to that in 2007?
Ensure brevity in your answer.  1.16. What is the ratio of the Exports(as % of merchandise exports) in Pakistan in 2005 to that in 2007?
Keep it short and to the point. 1.03. What is the ratio of the Exports(as % of merchandise exports) of Bolivia in 2005 to that in 2008?
Make the answer very short. 1.93. What is the ratio of the Exports(as % of merchandise exports) in Botswana in 2005 to that in 2008?
Your answer should be compact. 1.12. What is the ratio of the Exports(as % of merchandise exports) of Pakistan in 2005 to that in 2008?
Make the answer very short. 1.11. What is the ratio of the Exports(as % of merchandise exports) of Bangladesh in 2005 to that in 2009?
Keep it short and to the point. 0.98. What is the ratio of the Exports(as % of merchandise exports) of Bolivia in 2005 to that in 2009?
Offer a terse response. 1.94. What is the ratio of the Exports(as % of merchandise exports) of Botswana in 2005 to that in 2009?
Provide a short and direct response. 1.09. What is the ratio of the Exports(as % of merchandise exports) of Pakistan in 2005 to that in 2009?
Offer a terse response. 1.07. What is the ratio of the Exports(as % of merchandise exports) of Bangladesh in 2005 to that in 2010?
Your answer should be compact. 0.99. What is the ratio of the Exports(as % of merchandise exports) of Bolivia in 2005 to that in 2010?
Offer a very short reply. 1.75. What is the ratio of the Exports(as % of merchandise exports) of Botswana in 2005 to that in 2010?
Ensure brevity in your answer.  1.07. What is the ratio of the Exports(as % of merchandise exports) in Pakistan in 2005 to that in 2010?
Provide a succinct answer. 1.1. What is the ratio of the Exports(as % of merchandise exports) in Bangladesh in 2006 to that in 2007?
Offer a terse response. 1.03. What is the ratio of the Exports(as % of merchandise exports) in Bolivia in 2006 to that in 2007?
Offer a very short reply. 1.5. What is the ratio of the Exports(as % of merchandise exports) of Botswana in 2006 to that in 2007?
Provide a succinct answer. 1.09. What is the ratio of the Exports(as % of merchandise exports) of Pakistan in 2006 to that in 2007?
Keep it short and to the point. 1.02. What is the ratio of the Exports(as % of merchandise exports) in Bolivia in 2006 to that in 2008?
Provide a short and direct response. 1.81. What is the ratio of the Exports(as % of merchandise exports) in Botswana in 2006 to that in 2008?
Give a very brief answer. 1.05. What is the ratio of the Exports(as % of merchandise exports) in Pakistan in 2006 to that in 2008?
Keep it short and to the point. 1.11. What is the ratio of the Exports(as % of merchandise exports) in Bangladesh in 2006 to that in 2009?
Your answer should be very brief. 0.99. What is the ratio of the Exports(as % of merchandise exports) in Bolivia in 2006 to that in 2009?
Your answer should be very brief. 1.82. What is the ratio of the Exports(as % of merchandise exports) of Botswana in 2006 to that in 2009?
Make the answer very short. 1.03. What is the ratio of the Exports(as % of merchandise exports) of Pakistan in 2006 to that in 2009?
Offer a very short reply. 1.06. What is the ratio of the Exports(as % of merchandise exports) of Bangladesh in 2006 to that in 2010?
Give a very brief answer. 1. What is the ratio of the Exports(as % of merchandise exports) of Bolivia in 2006 to that in 2010?
Make the answer very short. 1.64. What is the ratio of the Exports(as % of merchandise exports) of Pakistan in 2006 to that in 2010?
Give a very brief answer. 1.1. What is the ratio of the Exports(as % of merchandise exports) in Bangladesh in 2007 to that in 2008?
Your answer should be very brief. 0.96. What is the ratio of the Exports(as % of merchandise exports) of Bolivia in 2007 to that in 2008?
Provide a succinct answer. 1.21. What is the ratio of the Exports(as % of merchandise exports) in Botswana in 2007 to that in 2008?
Provide a short and direct response. 0.96. What is the ratio of the Exports(as % of merchandise exports) of Pakistan in 2007 to that in 2008?
Keep it short and to the point. 1.08. What is the ratio of the Exports(as % of merchandise exports) in Bangladesh in 2007 to that in 2009?
Make the answer very short. 0.95. What is the ratio of the Exports(as % of merchandise exports) of Bolivia in 2007 to that in 2009?
Provide a short and direct response. 1.21. What is the ratio of the Exports(as % of merchandise exports) of Pakistan in 2007 to that in 2009?
Your answer should be compact. 1.04. What is the ratio of the Exports(as % of merchandise exports) of Bangladesh in 2007 to that in 2010?
Keep it short and to the point. 0.96. What is the ratio of the Exports(as % of merchandise exports) of Bolivia in 2007 to that in 2010?
Give a very brief answer. 1.09. What is the ratio of the Exports(as % of merchandise exports) in Botswana in 2007 to that in 2010?
Your answer should be compact. 0.92. What is the ratio of the Exports(as % of merchandise exports) of Pakistan in 2007 to that in 2010?
Provide a succinct answer. 1.07. What is the ratio of the Exports(as % of merchandise exports) in Bangladesh in 2008 to that in 2009?
Give a very brief answer. 0.99. What is the ratio of the Exports(as % of merchandise exports) in Botswana in 2008 to that in 2009?
Keep it short and to the point. 0.98. What is the ratio of the Exports(as % of merchandise exports) of Pakistan in 2008 to that in 2009?
Provide a succinct answer. 0.96. What is the ratio of the Exports(as % of merchandise exports) in Bangladesh in 2008 to that in 2010?
Provide a succinct answer. 1. What is the ratio of the Exports(as % of merchandise exports) of Bolivia in 2008 to that in 2010?
Offer a terse response. 0.91. What is the ratio of the Exports(as % of merchandise exports) of Botswana in 2008 to that in 2010?
Offer a terse response. 0.96. What is the ratio of the Exports(as % of merchandise exports) of Pakistan in 2008 to that in 2010?
Your response must be concise. 0.99. What is the ratio of the Exports(as % of merchandise exports) in Bangladesh in 2009 to that in 2010?
Give a very brief answer. 1.01. What is the ratio of the Exports(as % of merchandise exports) in Bolivia in 2009 to that in 2010?
Give a very brief answer. 0.9. What is the ratio of the Exports(as % of merchandise exports) in Botswana in 2009 to that in 2010?
Keep it short and to the point. 0.98. What is the ratio of the Exports(as % of merchandise exports) of Pakistan in 2009 to that in 2010?
Ensure brevity in your answer.  1.03. What is the difference between the highest and the second highest Exports(as % of merchandise exports) of Bangladesh?
Keep it short and to the point. 0.79. What is the difference between the highest and the second highest Exports(as % of merchandise exports) of Bolivia?
Your response must be concise. 2.38. What is the difference between the highest and the second highest Exports(as % of merchandise exports) in Botswana?
Provide a short and direct response. 0.28. What is the difference between the highest and the second highest Exports(as % of merchandise exports) in Pakistan?
Provide a short and direct response. 3.21. What is the difference between the highest and the lowest Exports(as % of merchandise exports) of Bangladesh?
Offer a very short reply. 4.42. What is the difference between the highest and the lowest Exports(as % of merchandise exports) in Bolivia?
Ensure brevity in your answer.  7.81. What is the difference between the highest and the lowest Exports(as % of merchandise exports) of Botswana?
Keep it short and to the point. 12.34. What is the difference between the highest and the lowest Exports(as % of merchandise exports) in Pakistan?
Offer a very short reply. 11.5. 